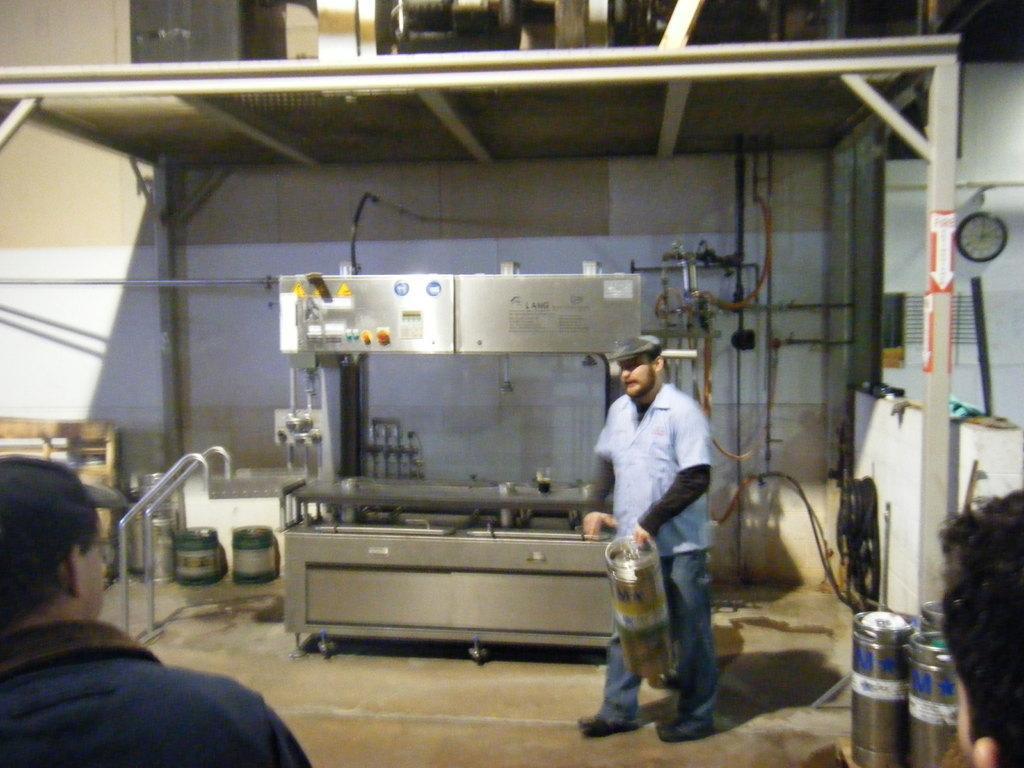In one or two sentences, can you explain what this image depicts? This is the picture of a place where we have a person holding something and behind there is a machine and around there are some other people, things and a clock to the wall. 